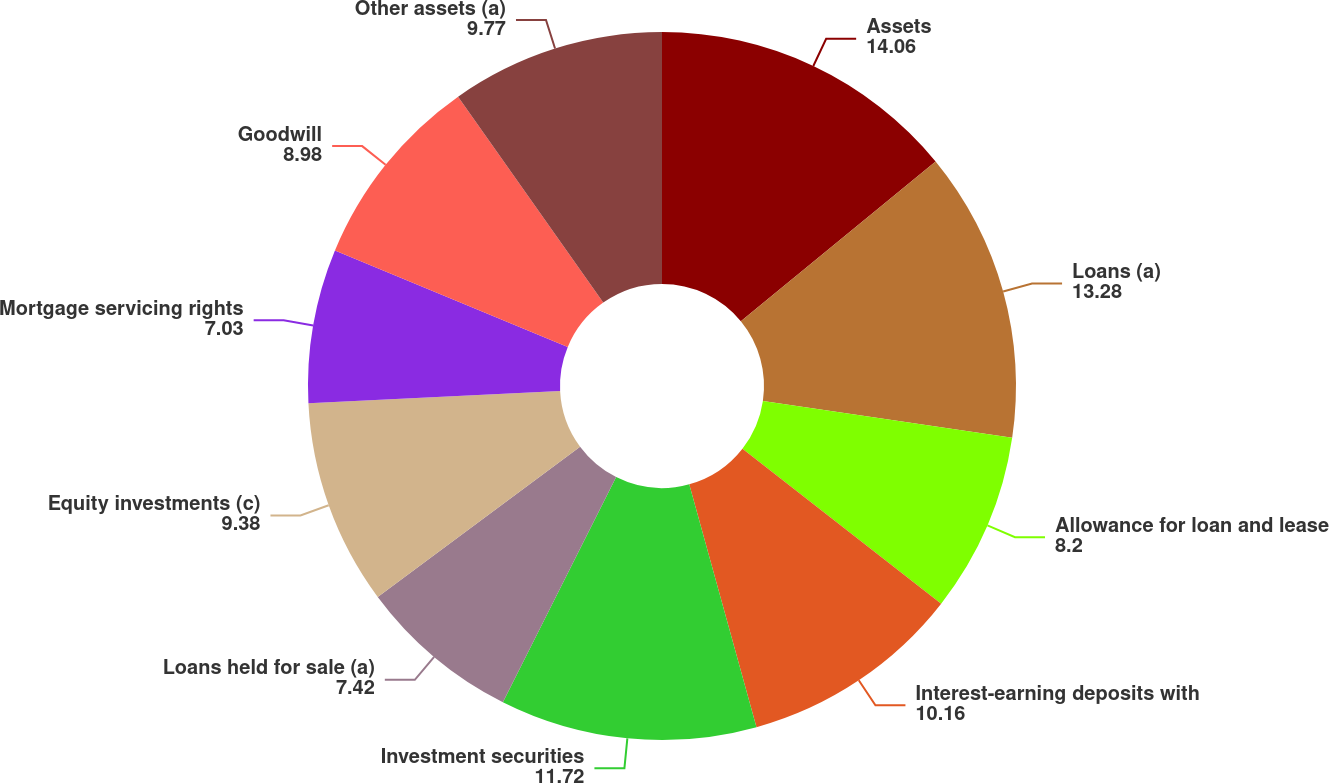Convert chart to OTSL. <chart><loc_0><loc_0><loc_500><loc_500><pie_chart><fcel>Assets<fcel>Loans (a)<fcel>Allowance for loan and lease<fcel>Interest-earning deposits with<fcel>Investment securities<fcel>Loans held for sale (a)<fcel>Equity investments (c)<fcel>Mortgage servicing rights<fcel>Goodwill<fcel>Other assets (a)<nl><fcel>14.06%<fcel>13.28%<fcel>8.2%<fcel>10.16%<fcel>11.72%<fcel>7.42%<fcel>9.38%<fcel>7.03%<fcel>8.98%<fcel>9.77%<nl></chart> 